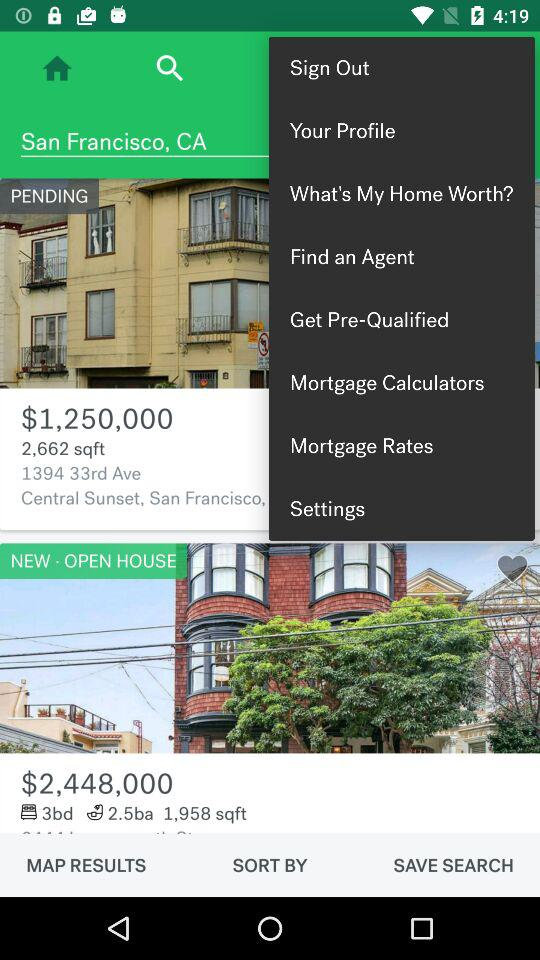What is the current location? The current location is San Francisco, CA. 